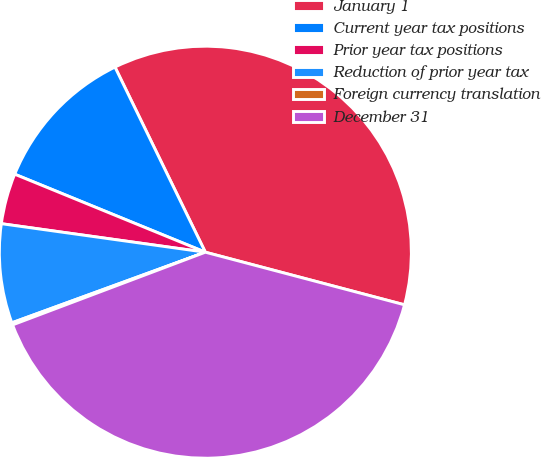Convert chart. <chart><loc_0><loc_0><loc_500><loc_500><pie_chart><fcel>January 1<fcel>Current year tax positions<fcel>Prior year tax positions<fcel>Reduction of prior year tax<fcel>Foreign currency translation<fcel>December 31<nl><fcel>36.34%<fcel>11.59%<fcel>3.97%<fcel>7.78%<fcel>0.17%<fcel>40.15%<nl></chart> 